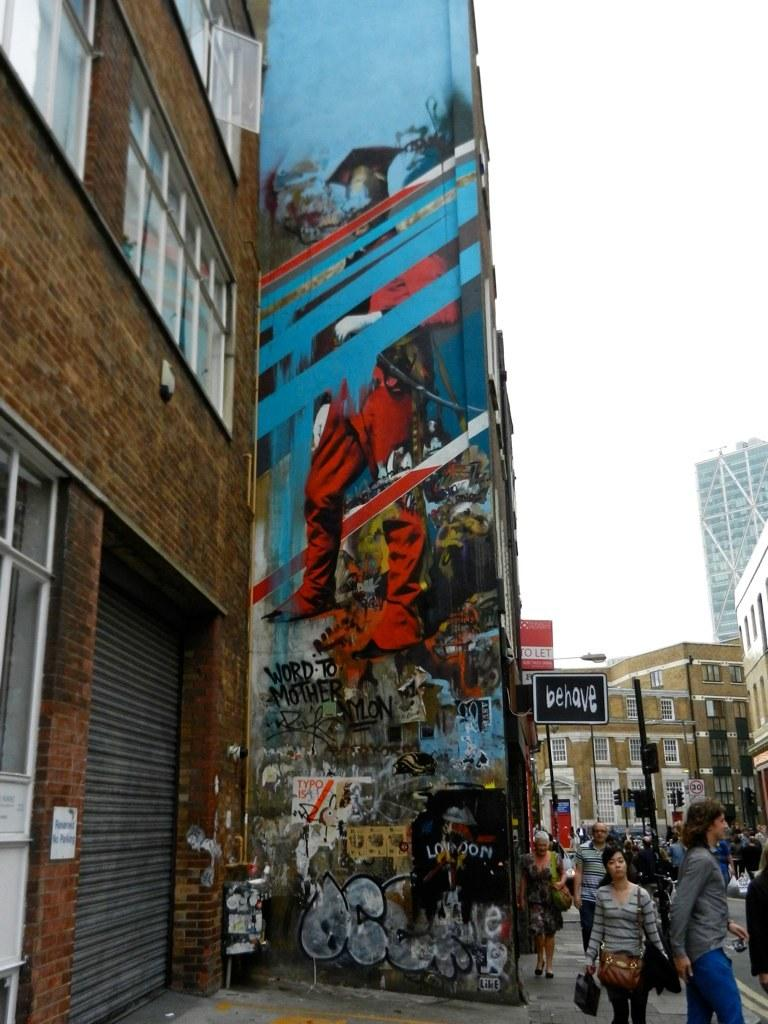How many people are in the group visible in the image? There is a group of people in the image, but the exact number cannot be determined from the provided facts. What is the purpose of the shutter in the image? The purpose of the shutter in the image cannot be determined from the provided facts. What information can be found on the name boards in the image? The information on the name boards in the image cannot be determined from the provided facts. What type of bags are visible in the image? The type of bags visible in the image cannot be determined from the provided facts. What is the subject of the painting on the wall in the image? The subject of the painting on the wall in the image cannot be determined from the provided facts. How many buildings with windows are visible in the image? There are buildings with windows in the image, but the exact number cannot be determined from the provided facts. What are the objects in the image? The objects in the image cannot be determined from the provided facts. What is the color of the sky in the background of the image? The color of the sky in the background of the image cannot be determined from the provided facts. What type of soap is being used by the minister in the image? There is no minister or soap present in the image. What is the lead character doing in the image? There is no lead character present in the image. 